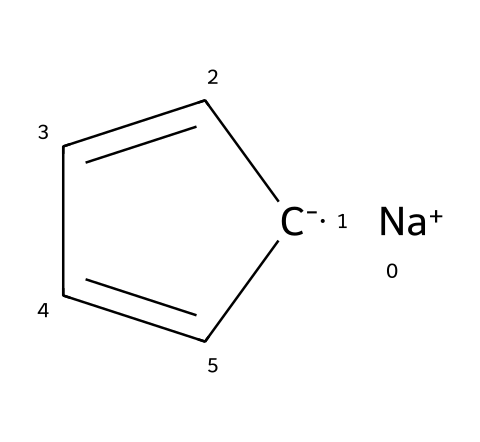What is the central metal ion in this compound? The compound contains sodium ([Na+]) as the cation, which acts as the central metal ion.
Answer: sodium How many carbon atoms are present in sodium cyclopentadienide? The structure indicates a cyclopentadienyl anion, comprised of five carbon atoms in a cyclic arrangement.
Answer: five What type of bonding is predominant in this organometallic compound? The compound contains ionic bonding between sodium and the cyclopentadienyl anion, coupled with covalent bonding between the carbon atoms.
Answer: ionic and covalent What is the charge of the cyclopentadienyl part in this molecule? The cyclopentadienyl anion is denoted by C- in the SMILES representation, indicating that it carries a negative charge.
Answer: negative What geometric arrangement does the cyclopentadienyl group exhibit? The cyclopentadienyl group is planar due to the overlapping p-orbitals of the carbon atoms, resulting in a cyclic, flat structure.
Answer: planar How many double bonds are present in the cyclopentadienyl ring? The representation of the cyclopentadienyl structure shows two double bonds between carbon atoms within the five-membered ring.
Answer: two What classification does sodium cyclopentadienide fall under? Sodium cyclopentadienide is classified as an organometallic compound due to the presence of a metal (sodium) bonded to a carbon-containing anion (cyclopentadienyl).
Answer: organometallic 